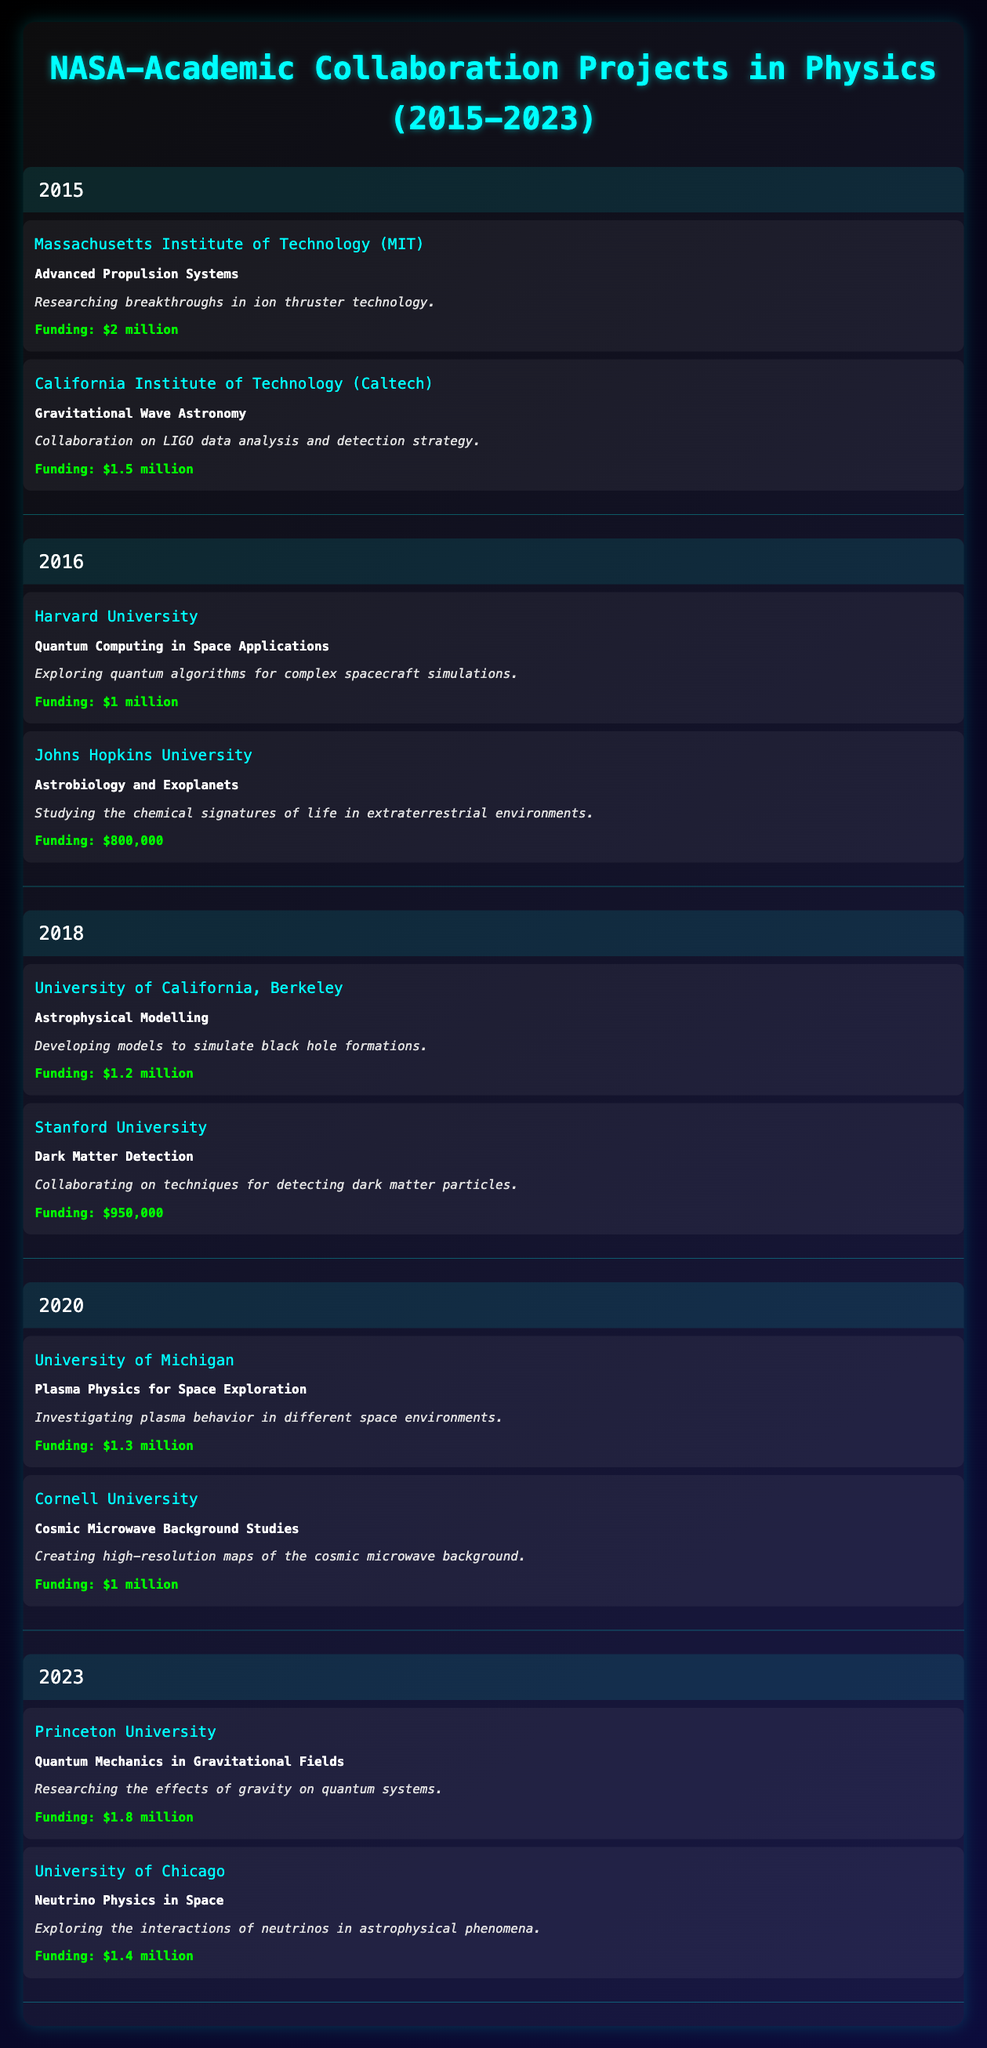What is the total funding amount for all projects in 2015? In 2015, there are two projects with funding amounts of $2 million (MIT) and $1.5 million (Caltech). Adding these together gives a total of $2 million + $1.5 million = $3.5 million.
Answer: $3.5 million Which institution received the least funding in 2016? In 2016, there are two projects: Harvard University received $1 million and Johns Hopkins University received $800,000. Comparing these, $800,000 is the lesser amount.
Answer: Johns Hopkins University Did Stanford University participate in more than one project during the period 2015 to 2023? According to the data, Stanford University only participated in one project, "Dark Matter Detection" in 2018. Thus, the answer is no.
Answer: No What is the average funding amount for projects in 2020? In 2020, there are two projects: University of Michigan received $1.3 million and Cornell University received $1 million. The total funding is $1.3 million + $1 million = $2.3 million. Dividing by the number of projects (2) gives an average of $2.3 million / 2 = $1.15 million.
Answer: $1.15 million Which institution received the highest funding in 2023? In 2023, there are two projects: Princeton University received $1.8 million for "Quantum Mechanics in Gravitational Fields" and University of Chicago received $1.4 million for "Neutrino Physics in Space". Since $1.8 million is greater than $1.4 million, Princeton University received the highest funding.
Answer: Princeton University How many projects involved quantum computing between 2015 and 2023? From the table, there is one project explicitly mentioning quantum computing, which is at Harvard University in 2016. Since no other project mentions quantum computing, the answer is one.
Answer: 1 What was the total funding for all collaboration projects from 2015 to 2023? By adding up the funding from all the projects listed: $2 million (2015) + $1.5 million (2015) + $1 million (2016) + $800,000 (2016) + $1.2 million (2018) + $950,000 (2018) + $1.3 million (2020) + $1 million (2020) + $1.8 million (2023) + $1.4 million (2023) yields a total of $12.1 million.
Answer: $12.1 million Is the "Cosmic Microwave Background Studies" project related to dark matter detection? "Cosmic Microwave Background Studies" and "Dark Matter Detection" are listed as separate projects; their descriptions do not indicate a direct relation. Thus, the answer is no.
Answer: No How much more funding did the MIT project receive compared to the Johns Hopkins project in 2016? Comparing the projects, the MIT project received $2 million, and the Johns Hopkins project received $800,000. Subtracting these gives $2 million - $800,000 = $1.2 million more for MIT.
Answer: $1.2 million 